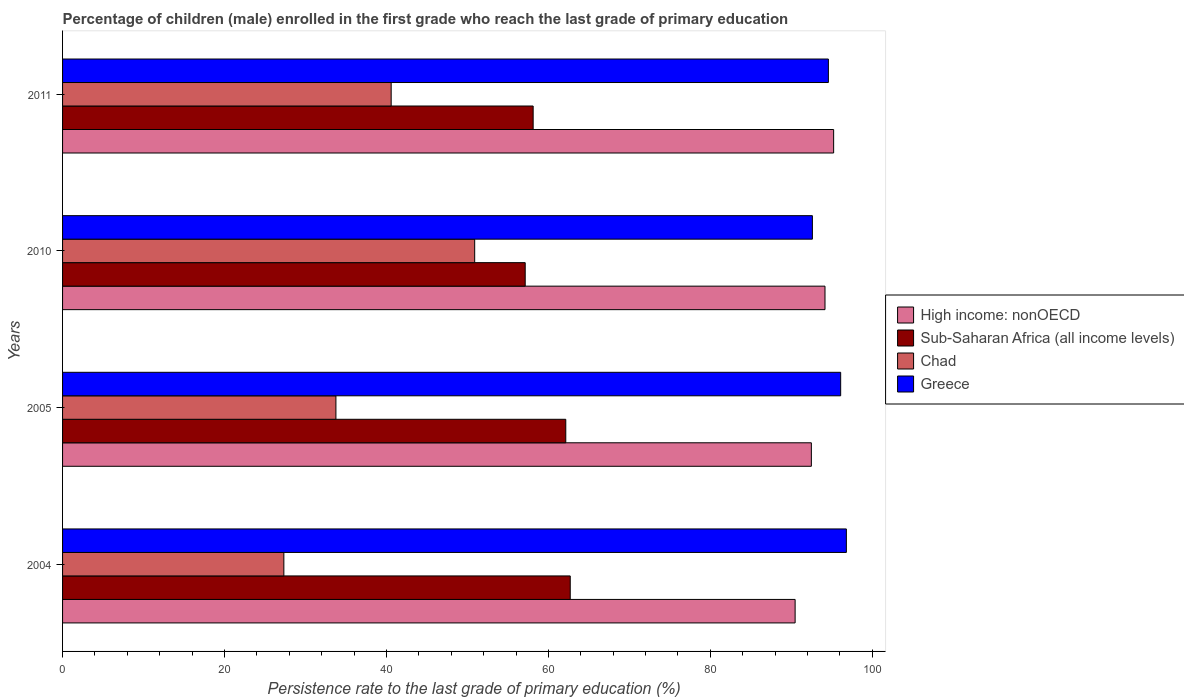How many different coloured bars are there?
Offer a terse response. 4. How many groups of bars are there?
Make the answer very short. 4. Are the number of bars on each tick of the Y-axis equal?
Your answer should be compact. Yes. How many bars are there on the 4th tick from the top?
Give a very brief answer. 4. How many bars are there on the 2nd tick from the bottom?
Your answer should be very brief. 4. What is the label of the 1st group of bars from the top?
Offer a very short reply. 2011. What is the persistence rate of children in High income: nonOECD in 2005?
Give a very brief answer. 92.48. Across all years, what is the maximum persistence rate of children in Greece?
Give a very brief answer. 96.8. Across all years, what is the minimum persistence rate of children in Greece?
Keep it short and to the point. 92.6. In which year was the persistence rate of children in Chad minimum?
Keep it short and to the point. 2004. What is the total persistence rate of children in Sub-Saharan Africa (all income levels) in the graph?
Your response must be concise. 240.1. What is the difference between the persistence rate of children in High income: nonOECD in 2004 and that in 2010?
Your answer should be very brief. -3.69. What is the difference between the persistence rate of children in Greece in 2004 and the persistence rate of children in Chad in 2005?
Give a very brief answer. 63.04. What is the average persistence rate of children in Sub-Saharan Africa (all income levels) per year?
Offer a very short reply. 60.03. In the year 2011, what is the difference between the persistence rate of children in High income: nonOECD and persistence rate of children in Sub-Saharan Africa (all income levels)?
Provide a succinct answer. 37.11. What is the ratio of the persistence rate of children in Greece in 2004 to that in 2011?
Your answer should be compact. 1.02. What is the difference between the highest and the second highest persistence rate of children in Sub-Saharan Africa (all income levels)?
Your response must be concise. 0.55. What is the difference between the highest and the lowest persistence rate of children in High income: nonOECD?
Provide a short and direct response. 4.76. Is it the case that in every year, the sum of the persistence rate of children in Greece and persistence rate of children in Chad is greater than the sum of persistence rate of children in Sub-Saharan Africa (all income levels) and persistence rate of children in High income: nonOECD?
Offer a terse response. Yes. What does the 3rd bar from the top in 2011 represents?
Keep it short and to the point. Sub-Saharan Africa (all income levels). What does the 2nd bar from the bottom in 2004 represents?
Ensure brevity in your answer.  Sub-Saharan Africa (all income levels). Is it the case that in every year, the sum of the persistence rate of children in High income: nonOECD and persistence rate of children in Chad is greater than the persistence rate of children in Greece?
Your answer should be very brief. Yes. What is the difference between two consecutive major ticks on the X-axis?
Keep it short and to the point. 20. Are the values on the major ticks of X-axis written in scientific E-notation?
Your answer should be compact. No. Where does the legend appear in the graph?
Give a very brief answer. Center right. How many legend labels are there?
Your response must be concise. 4. How are the legend labels stacked?
Offer a very short reply. Vertical. What is the title of the graph?
Provide a succinct answer. Percentage of children (male) enrolled in the first grade who reach the last grade of primary education. Does "Sierra Leone" appear as one of the legend labels in the graph?
Give a very brief answer. No. What is the label or title of the X-axis?
Give a very brief answer. Persistence rate to the last grade of primary education (%). What is the Persistence rate to the last grade of primary education (%) of High income: nonOECD in 2004?
Offer a terse response. 90.47. What is the Persistence rate to the last grade of primary education (%) in Sub-Saharan Africa (all income levels) in 2004?
Offer a terse response. 62.7. What is the Persistence rate to the last grade of primary education (%) in Chad in 2004?
Offer a terse response. 27.33. What is the Persistence rate to the last grade of primary education (%) of Greece in 2004?
Keep it short and to the point. 96.8. What is the Persistence rate to the last grade of primary education (%) in High income: nonOECD in 2005?
Your response must be concise. 92.48. What is the Persistence rate to the last grade of primary education (%) in Sub-Saharan Africa (all income levels) in 2005?
Give a very brief answer. 62.15. What is the Persistence rate to the last grade of primary education (%) in Chad in 2005?
Keep it short and to the point. 33.76. What is the Persistence rate to the last grade of primary education (%) in Greece in 2005?
Your answer should be compact. 96.1. What is the Persistence rate to the last grade of primary education (%) of High income: nonOECD in 2010?
Your answer should be very brief. 94.16. What is the Persistence rate to the last grade of primary education (%) of Sub-Saharan Africa (all income levels) in 2010?
Give a very brief answer. 57.14. What is the Persistence rate to the last grade of primary education (%) of Chad in 2010?
Offer a very short reply. 50.9. What is the Persistence rate to the last grade of primary education (%) in Greece in 2010?
Offer a terse response. 92.6. What is the Persistence rate to the last grade of primary education (%) of High income: nonOECD in 2011?
Provide a short and direct response. 95.23. What is the Persistence rate to the last grade of primary education (%) in Sub-Saharan Africa (all income levels) in 2011?
Provide a short and direct response. 58.12. What is the Persistence rate to the last grade of primary education (%) of Chad in 2011?
Make the answer very short. 40.58. What is the Persistence rate to the last grade of primary education (%) in Greece in 2011?
Provide a succinct answer. 94.58. Across all years, what is the maximum Persistence rate to the last grade of primary education (%) of High income: nonOECD?
Keep it short and to the point. 95.23. Across all years, what is the maximum Persistence rate to the last grade of primary education (%) in Sub-Saharan Africa (all income levels)?
Ensure brevity in your answer.  62.7. Across all years, what is the maximum Persistence rate to the last grade of primary education (%) in Chad?
Make the answer very short. 50.9. Across all years, what is the maximum Persistence rate to the last grade of primary education (%) in Greece?
Provide a succinct answer. 96.8. Across all years, what is the minimum Persistence rate to the last grade of primary education (%) of High income: nonOECD?
Give a very brief answer. 90.47. Across all years, what is the minimum Persistence rate to the last grade of primary education (%) in Sub-Saharan Africa (all income levels)?
Provide a short and direct response. 57.14. Across all years, what is the minimum Persistence rate to the last grade of primary education (%) in Chad?
Your response must be concise. 27.33. Across all years, what is the minimum Persistence rate to the last grade of primary education (%) of Greece?
Ensure brevity in your answer.  92.6. What is the total Persistence rate to the last grade of primary education (%) of High income: nonOECD in the graph?
Your answer should be very brief. 372.34. What is the total Persistence rate to the last grade of primary education (%) in Sub-Saharan Africa (all income levels) in the graph?
Provide a succinct answer. 240.1. What is the total Persistence rate to the last grade of primary education (%) of Chad in the graph?
Offer a terse response. 152.57. What is the total Persistence rate to the last grade of primary education (%) of Greece in the graph?
Provide a succinct answer. 380.08. What is the difference between the Persistence rate to the last grade of primary education (%) of High income: nonOECD in 2004 and that in 2005?
Your answer should be compact. -2. What is the difference between the Persistence rate to the last grade of primary education (%) in Sub-Saharan Africa (all income levels) in 2004 and that in 2005?
Your answer should be compact. 0.55. What is the difference between the Persistence rate to the last grade of primary education (%) of Chad in 2004 and that in 2005?
Provide a succinct answer. -6.43. What is the difference between the Persistence rate to the last grade of primary education (%) in Greece in 2004 and that in 2005?
Ensure brevity in your answer.  0.7. What is the difference between the Persistence rate to the last grade of primary education (%) in High income: nonOECD in 2004 and that in 2010?
Give a very brief answer. -3.69. What is the difference between the Persistence rate to the last grade of primary education (%) of Sub-Saharan Africa (all income levels) in 2004 and that in 2010?
Offer a very short reply. 5.56. What is the difference between the Persistence rate to the last grade of primary education (%) in Chad in 2004 and that in 2010?
Ensure brevity in your answer.  -23.57. What is the difference between the Persistence rate to the last grade of primary education (%) of Greece in 2004 and that in 2010?
Ensure brevity in your answer.  4.2. What is the difference between the Persistence rate to the last grade of primary education (%) of High income: nonOECD in 2004 and that in 2011?
Your response must be concise. -4.76. What is the difference between the Persistence rate to the last grade of primary education (%) of Sub-Saharan Africa (all income levels) in 2004 and that in 2011?
Ensure brevity in your answer.  4.58. What is the difference between the Persistence rate to the last grade of primary education (%) in Chad in 2004 and that in 2011?
Give a very brief answer. -13.25. What is the difference between the Persistence rate to the last grade of primary education (%) of Greece in 2004 and that in 2011?
Your answer should be compact. 2.22. What is the difference between the Persistence rate to the last grade of primary education (%) of High income: nonOECD in 2005 and that in 2010?
Your answer should be very brief. -1.68. What is the difference between the Persistence rate to the last grade of primary education (%) in Sub-Saharan Africa (all income levels) in 2005 and that in 2010?
Your response must be concise. 5.01. What is the difference between the Persistence rate to the last grade of primary education (%) of Chad in 2005 and that in 2010?
Keep it short and to the point. -17.14. What is the difference between the Persistence rate to the last grade of primary education (%) in Greece in 2005 and that in 2010?
Give a very brief answer. 3.49. What is the difference between the Persistence rate to the last grade of primary education (%) in High income: nonOECD in 2005 and that in 2011?
Offer a terse response. -2.75. What is the difference between the Persistence rate to the last grade of primary education (%) of Sub-Saharan Africa (all income levels) in 2005 and that in 2011?
Your answer should be compact. 4.03. What is the difference between the Persistence rate to the last grade of primary education (%) of Chad in 2005 and that in 2011?
Make the answer very short. -6.82. What is the difference between the Persistence rate to the last grade of primary education (%) in Greece in 2005 and that in 2011?
Offer a terse response. 1.52. What is the difference between the Persistence rate to the last grade of primary education (%) of High income: nonOECD in 2010 and that in 2011?
Keep it short and to the point. -1.07. What is the difference between the Persistence rate to the last grade of primary education (%) of Sub-Saharan Africa (all income levels) in 2010 and that in 2011?
Your answer should be very brief. -0.98. What is the difference between the Persistence rate to the last grade of primary education (%) of Chad in 2010 and that in 2011?
Keep it short and to the point. 10.31. What is the difference between the Persistence rate to the last grade of primary education (%) of Greece in 2010 and that in 2011?
Make the answer very short. -1.98. What is the difference between the Persistence rate to the last grade of primary education (%) of High income: nonOECD in 2004 and the Persistence rate to the last grade of primary education (%) of Sub-Saharan Africa (all income levels) in 2005?
Make the answer very short. 28.33. What is the difference between the Persistence rate to the last grade of primary education (%) of High income: nonOECD in 2004 and the Persistence rate to the last grade of primary education (%) of Chad in 2005?
Your answer should be very brief. 56.71. What is the difference between the Persistence rate to the last grade of primary education (%) in High income: nonOECD in 2004 and the Persistence rate to the last grade of primary education (%) in Greece in 2005?
Provide a short and direct response. -5.62. What is the difference between the Persistence rate to the last grade of primary education (%) of Sub-Saharan Africa (all income levels) in 2004 and the Persistence rate to the last grade of primary education (%) of Chad in 2005?
Provide a short and direct response. 28.94. What is the difference between the Persistence rate to the last grade of primary education (%) of Sub-Saharan Africa (all income levels) in 2004 and the Persistence rate to the last grade of primary education (%) of Greece in 2005?
Make the answer very short. -33.4. What is the difference between the Persistence rate to the last grade of primary education (%) of Chad in 2004 and the Persistence rate to the last grade of primary education (%) of Greece in 2005?
Give a very brief answer. -68.77. What is the difference between the Persistence rate to the last grade of primary education (%) in High income: nonOECD in 2004 and the Persistence rate to the last grade of primary education (%) in Sub-Saharan Africa (all income levels) in 2010?
Offer a very short reply. 33.34. What is the difference between the Persistence rate to the last grade of primary education (%) in High income: nonOECD in 2004 and the Persistence rate to the last grade of primary education (%) in Chad in 2010?
Provide a short and direct response. 39.57. What is the difference between the Persistence rate to the last grade of primary education (%) of High income: nonOECD in 2004 and the Persistence rate to the last grade of primary education (%) of Greece in 2010?
Offer a terse response. -2.13. What is the difference between the Persistence rate to the last grade of primary education (%) of Sub-Saharan Africa (all income levels) in 2004 and the Persistence rate to the last grade of primary education (%) of Chad in 2010?
Your answer should be very brief. 11.8. What is the difference between the Persistence rate to the last grade of primary education (%) in Sub-Saharan Africa (all income levels) in 2004 and the Persistence rate to the last grade of primary education (%) in Greece in 2010?
Your answer should be compact. -29.91. What is the difference between the Persistence rate to the last grade of primary education (%) of Chad in 2004 and the Persistence rate to the last grade of primary education (%) of Greece in 2010?
Give a very brief answer. -65.27. What is the difference between the Persistence rate to the last grade of primary education (%) in High income: nonOECD in 2004 and the Persistence rate to the last grade of primary education (%) in Sub-Saharan Africa (all income levels) in 2011?
Make the answer very short. 32.35. What is the difference between the Persistence rate to the last grade of primary education (%) in High income: nonOECD in 2004 and the Persistence rate to the last grade of primary education (%) in Chad in 2011?
Ensure brevity in your answer.  49.89. What is the difference between the Persistence rate to the last grade of primary education (%) in High income: nonOECD in 2004 and the Persistence rate to the last grade of primary education (%) in Greece in 2011?
Ensure brevity in your answer.  -4.11. What is the difference between the Persistence rate to the last grade of primary education (%) in Sub-Saharan Africa (all income levels) in 2004 and the Persistence rate to the last grade of primary education (%) in Chad in 2011?
Give a very brief answer. 22.12. What is the difference between the Persistence rate to the last grade of primary education (%) of Sub-Saharan Africa (all income levels) in 2004 and the Persistence rate to the last grade of primary education (%) of Greece in 2011?
Your answer should be very brief. -31.88. What is the difference between the Persistence rate to the last grade of primary education (%) of Chad in 2004 and the Persistence rate to the last grade of primary education (%) of Greece in 2011?
Your answer should be very brief. -67.25. What is the difference between the Persistence rate to the last grade of primary education (%) in High income: nonOECD in 2005 and the Persistence rate to the last grade of primary education (%) in Sub-Saharan Africa (all income levels) in 2010?
Your answer should be very brief. 35.34. What is the difference between the Persistence rate to the last grade of primary education (%) of High income: nonOECD in 2005 and the Persistence rate to the last grade of primary education (%) of Chad in 2010?
Your answer should be very brief. 41.58. What is the difference between the Persistence rate to the last grade of primary education (%) of High income: nonOECD in 2005 and the Persistence rate to the last grade of primary education (%) of Greece in 2010?
Provide a succinct answer. -0.13. What is the difference between the Persistence rate to the last grade of primary education (%) in Sub-Saharan Africa (all income levels) in 2005 and the Persistence rate to the last grade of primary education (%) in Chad in 2010?
Keep it short and to the point. 11.25. What is the difference between the Persistence rate to the last grade of primary education (%) in Sub-Saharan Africa (all income levels) in 2005 and the Persistence rate to the last grade of primary education (%) in Greece in 2010?
Your response must be concise. -30.46. What is the difference between the Persistence rate to the last grade of primary education (%) in Chad in 2005 and the Persistence rate to the last grade of primary education (%) in Greece in 2010?
Ensure brevity in your answer.  -58.84. What is the difference between the Persistence rate to the last grade of primary education (%) of High income: nonOECD in 2005 and the Persistence rate to the last grade of primary education (%) of Sub-Saharan Africa (all income levels) in 2011?
Offer a very short reply. 34.36. What is the difference between the Persistence rate to the last grade of primary education (%) of High income: nonOECD in 2005 and the Persistence rate to the last grade of primary education (%) of Chad in 2011?
Your answer should be compact. 51.89. What is the difference between the Persistence rate to the last grade of primary education (%) of High income: nonOECD in 2005 and the Persistence rate to the last grade of primary education (%) of Greece in 2011?
Offer a very short reply. -2.1. What is the difference between the Persistence rate to the last grade of primary education (%) in Sub-Saharan Africa (all income levels) in 2005 and the Persistence rate to the last grade of primary education (%) in Chad in 2011?
Make the answer very short. 21.56. What is the difference between the Persistence rate to the last grade of primary education (%) in Sub-Saharan Africa (all income levels) in 2005 and the Persistence rate to the last grade of primary education (%) in Greece in 2011?
Your response must be concise. -32.43. What is the difference between the Persistence rate to the last grade of primary education (%) of Chad in 2005 and the Persistence rate to the last grade of primary education (%) of Greece in 2011?
Provide a succinct answer. -60.82. What is the difference between the Persistence rate to the last grade of primary education (%) of High income: nonOECD in 2010 and the Persistence rate to the last grade of primary education (%) of Sub-Saharan Africa (all income levels) in 2011?
Your answer should be compact. 36.04. What is the difference between the Persistence rate to the last grade of primary education (%) in High income: nonOECD in 2010 and the Persistence rate to the last grade of primary education (%) in Chad in 2011?
Ensure brevity in your answer.  53.58. What is the difference between the Persistence rate to the last grade of primary education (%) in High income: nonOECD in 2010 and the Persistence rate to the last grade of primary education (%) in Greece in 2011?
Your response must be concise. -0.42. What is the difference between the Persistence rate to the last grade of primary education (%) in Sub-Saharan Africa (all income levels) in 2010 and the Persistence rate to the last grade of primary education (%) in Chad in 2011?
Provide a succinct answer. 16.55. What is the difference between the Persistence rate to the last grade of primary education (%) in Sub-Saharan Africa (all income levels) in 2010 and the Persistence rate to the last grade of primary education (%) in Greece in 2011?
Provide a short and direct response. -37.44. What is the difference between the Persistence rate to the last grade of primary education (%) of Chad in 2010 and the Persistence rate to the last grade of primary education (%) of Greece in 2011?
Your answer should be very brief. -43.68. What is the average Persistence rate to the last grade of primary education (%) in High income: nonOECD per year?
Make the answer very short. 93.08. What is the average Persistence rate to the last grade of primary education (%) in Sub-Saharan Africa (all income levels) per year?
Keep it short and to the point. 60.03. What is the average Persistence rate to the last grade of primary education (%) in Chad per year?
Give a very brief answer. 38.14. What is the average Persistence rate to the last grade of primary education (%) in Greece per year?
Offer a terse response. 95.02. In the year 2004, what is the difference between the Persistence rate to the last grade of primary education (%) of High income: nonOECD and Persistence rate to the last grade of primary education (%) of Sub-Saharan Africa (all income levels)?
Your response must be concise. 27.77. In the year 2004, what is the difference between the Persistence rate to the last grade of primary education (%) of High income: nonOECD and Persistence rate to the last grade of primary education (%) of Chad?
Provide a short and direct response. 63.14. In the year 2004, what is the difference between the Persistence rate to the last grade of primary education (%) in High income: nonOECD and Persistence rate to the last grade of primary education (%) in Greece?
Keep it short and to the point. -6.33. In the year 2004, what is the difference between the Persistence rate to the last grade of primary education (%) in Sub-Saharan Africa (all income levels) and Persistence rate to the last grade of primary education (%) in Chad?
Keep it short and to the point. 35.37. In the year 2004, what is the difference between the Persistence rate to the last grade of primary education (%) of Sub-Saharan Africa (all income levels) and Persistence rate to the last grade of primary education (%) of Greece?
Provide a short and direct response. -34.1. In the year 2004, what is the difference between the Persistence rate to the last grade of primary education (%) of Chad and Persistence rate to the last grade of primary education (%) of Greece?
Ensure brevity in your answer.  -69.47. In the year 2005, what is the difference between the Persistence rate to the last grade of primary education (%) in High income: nonOECD and Persistence rate to the last grade of primary education (%) in Sub-Saharan Africa (all income levels)?
Your answer should be very brief. 30.33. In the year 2005, what is the difference between the Persistence rate to the last grade of primary education (%) in High income: nonOECD and Persistence rate to the last grade of primary education (%) in Chad?
Give a very brief answer. 58.72. In the year 2005, what is the difference between the Persistence rate to the last grade of primary education (%) of High income: nonOECD and Persistence rate to the last grade of primary education (%) of Greece?
Offer a very short reply. -3.62. In the year 2005, what is the difference between the Persistence rate to the last grade of primary education (%) of Sub-Saharan Africa (all income levels) and Persistence rate to the last grade of primary education (%) of Chad?
Give a very brief answer. 28.39. In the year 2005, what is the difference between the Persistence rate to the last grade of primary education (%) of Sub-Saharan Africa (all income levels) and Persistence rate to the last grade of primary education (%) of Greece?
Your answer should be very brief. -33.95. In the year 2005, what is the difference between the Persistence rate to the last grade of primary education (%) of Chad and Persistence rate to the last grade of primary education (%) of Greece?
Offer a very short reply. -62.34. In the year 2010, what is the difference between the Persistence rate to the last grade of primary education (%) of High income: nonOECD and Persistence rate to the last grade of primary education (%) of Sub-Saharan Africa (all income levels)?
Offer a terse response. 37.02. In the year 2010, what is the difference between the Persistence rate to the last grade of primary education (%) of High income: nonOECD and Persistence rate to the last grade of primary education (%) of Chad?
Your answer should be compact. 43.26. In the year 2010, what is the difference between the Persistence rate to the last grade of primary education (%) in High income: nonOECD and Persistence rate to the last grade of primary education (%) in Greece?
Your response must be concise. 1.56. In the year 2010, what is the difference between the Persistence rate to the last grade of primary education (%) of Sub-Saharan Africa (all income levels) and Persistence rate to the last grade of primary education (%) of Chad?
Offer a very short reply. 6.24. In the year 2010, what is the difference between the Persistence rate to the last grade of primary education (%) of Sub-Saharan Africa (all income levels) and Persistence rate to the last grade of primary education (%) of Greece?
Offer a very short reply. -35.47. In the year 2010, what is the difference between the Persistence rate to the last grade of primary education (%) in Chad and Persistence rate to the last grade of primary education (%) in Greece?
Keep it short and to the point. -41.71. In the year 2011, what is the difference between the Persistence rate to the last grade of primary education (%) in High income: nonOECD and Persistence rate to the last grade of primary education (%) in Sub-Saharan Africa (all income levels)?
Provide a short and direct response. 37.11. In the year 2011, what is the difference between the Persistence rate to the last grade of primary education (%) of High income: nonOECD and Persistence rate to the last grade of primary education (%) of Chad?
Your answer should be very brief. 54.64. In the year 2011, what is the difference between the Persistence rate to the last grade of primary education (%) in High income: nonOECD and Persistence rate to the last grade of primary education (%) in Greece?
Offer a terse response. 0.65. In the year 2011, what is the difference between the Persistence rate to the last grade of primary education (%) in Sub-Saharan Africa (all income levels) and Persistence rate to the last grade of primary education (%) in Chad?
Make the answer very short. 17.54. In the year 2011, what is the difference between the Persistence rate to the last grade of primary education (%) of Sub-Saharan Africa (all income levels) and Persistence rate to the last grade of primary education (%) of Greece?
Keep it short and to the point. -36.46. In the year 2011, what is the difference between the Persistence rate to the last grade of primary education (%) of Chad and Persistence rate to the last grade of primary education (%) of Greece?
Your answer should be compact. -54. What is the ratio of the Persistence rate to the last grade of primary education (%) in High income: nonOECD in 2004 to that in 2005?
Provide a succinct answer. 0.98. What is the ratio of the Persistence rate to the last grade of primary education (%) in Sub-Saharan Africa (all income levels) in 2004 to that in 2005?
Keep it short and to the point. 1.01. What is the ratio of the Persistence rate to the last grade of primary education (%) in Chad in 2004 to that in 2005?
Make the answer very short. 0.81. What is the ratio of the Persistence rate to the last grade of primary education (%) of Greece in 2004 to that in 2005?
Make the answer very short. 1.01. What is the ratio of the Persistence rate to the last grade of primary education (%) in High income: nonOECD in 2004 to that in 2010?
Ensure brevity in your answer.  0.96. What is the ratio of the Persistence rate to the last grade of primary education (%) in Sub-Saharan Africa (all income levels) in 2004 to that in 2010?
Provide a succinct answer. 1.1. What is the ratio of the Persistence rate to the last grade of primary education (%) in Chad in 2004 to that in 2010?
Make the answer very short. 0.54. What is the ratio of the Persistence rate to the last grade of primary education (%) of Greece in 2004 to that in 2010?
Your response must be concise. 1.05. What is the ratio of the Persistence rate to the last grade of primary education (%) of High income: nonOECD in 2004 to that in 2011?
Provide a short and direct response. 0.95. What is the ratio of the Persistence rate to the last grade of primary education (%) of Sub-Saharan Africa (all income levels) in 2004 to that in 2011?
Provide a short and direct response. 1.08. What is the ratio of the Persistence rate to the last grade of primary education (%) in Chad in 2004 to that in 2011?
Offer a terse response. 0.67. What is the ratio of the Persistence rate to the last grade of primary education (%) in Greece in 2004 to that in 2011?
Your answer should be compact. 1.02. What is the ratio of the Persistence rate to the last grade of primary education (%) in High income: nonOECD in 2005 to that in 2010?
Make the answer very short. 0.98. What is the ratio of the Persistence rate to the last grade of primary education (%) in Sub-Saharan Africa (all income levels) in 2005 to that in 2010?
Ensure brevity in your answer.  1.09. What is the ratio of the Persistence rate to the last grade of primary education (%) in Chad in 2005 to that in 2010?
Your answer should be very brief. 0.66. What is the ratio of the Persistence rate to the last grade of primary education (%) of Greece in 2005 to that in 2010?
Make the answer very short. 1.04. What is the ratio of the Persistence rate to the last grade of primary education (%) of High income: nonOECD in 2005 to that in 2011?
Provide a short and direct response. 0.97. What is the ratio of the Persistence rate to the last grade of primary education (%) of Sub-Saharan Africa (all income levels) in 2005 to that in 2011?
Provide a short and direct response. 1.07. What is the ratio of the Persistence rate to the last grade of primary education (%) in Chad in 2005 to that in 2011?
Provide a succinct answer. 0.83. What is the ratio of the Persistence rate to the last grade of primary education (%) in Greece in 2005 to that in 2011?
Keep it short and to the point. 1.02. What is the ratio of the Persistence rate to the last grade of primary education (%) of High income: nonOECD in 2010 to that in 2011?
Your response must be concise. 0.99. What is the ratio of the Persistence rate to the last grade of primary education (%) of Sub-Saharan Africa (all income levels) in 2010 to that in 2011?
Your response must be concise. 0.98. What is the ratio of the Persistence rate to the last grade of primary education (%) of Chad in 2010 to that in 2011?
Your answer should be very brief. 1.25. What is the ratio of the Persistence rate to the last grade of primary education (%) in Greece in 2010 to that in 2011?
Provide a short and direct response. 0.98. What is the difference between the highest and the second highest Persistence rate to the last grade of primary education (%) of High income: nonOECD?
Offer a terse response. 1.07. What is the difference between the highest and the second highest Persistence rate to the last grade of primary education (%) in Sub-Saharan Africa (all income levels)?
Provide a succinct answer. 0.55. What is the difference between the highest and the second highest Persistence rate to the last grade of primary education (%) of Chad?
Keep it short and to the point. 10.31. What is the difference between the highest and the second highest Persistence rate to the last grade of primary education (%) in Greece?
Provide a succinct answer. 0.7. What is the difference between the highest and the lowest Persistence rate to the last grade of primary education (%) in High income: nonOECD?
Offer a very short reply. 4.76. What is the difference between the highest and the lowest Persistence rate to the last grade of primary education (%) in Sub-Saharan Africa (all income levels)?
Your answer should be compact. 5.56. What is the difference between the highest and the lowest Persistence rate to the last grade of primary education (%) of Chad?
Provide a succinct answer. 23.57. What is the difference between the highest and the lowest Persistence rate to the last grade of primary education (%) of Greece?
Your answer should be compact. 4.2. 